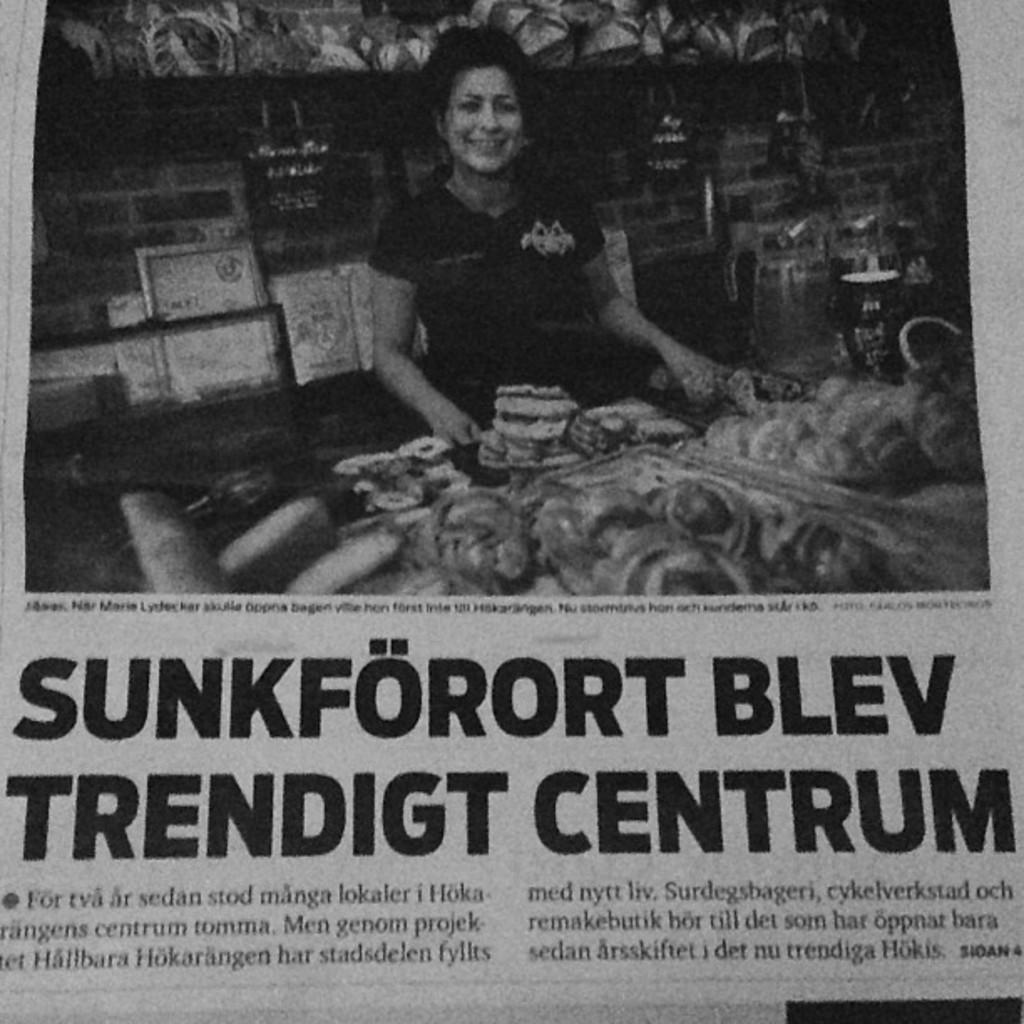<image>
Present a compact description of the photo's key features. A newspaper headline ends with the word Centrum. 